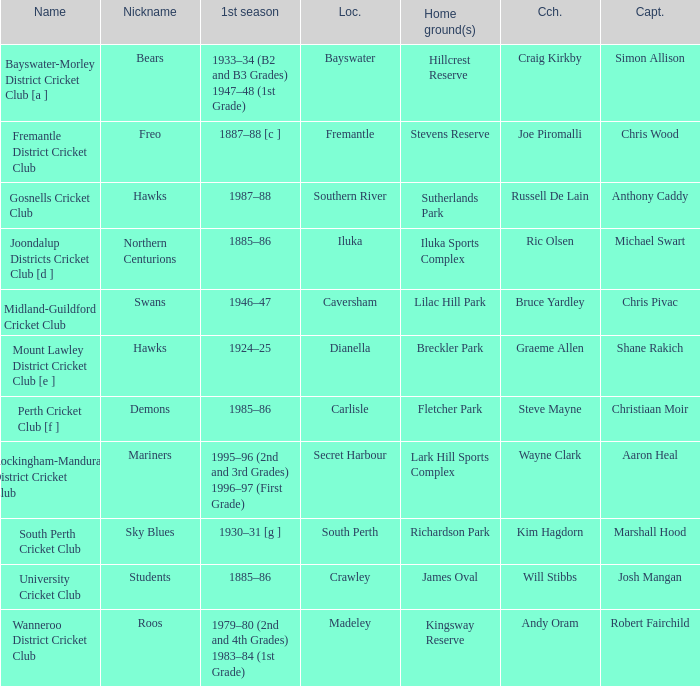What is the dates where Hillcrest Reserve is the home grounds? 1933–34 (B2 and B3 Grades) 1947–48 (1st Grade). 